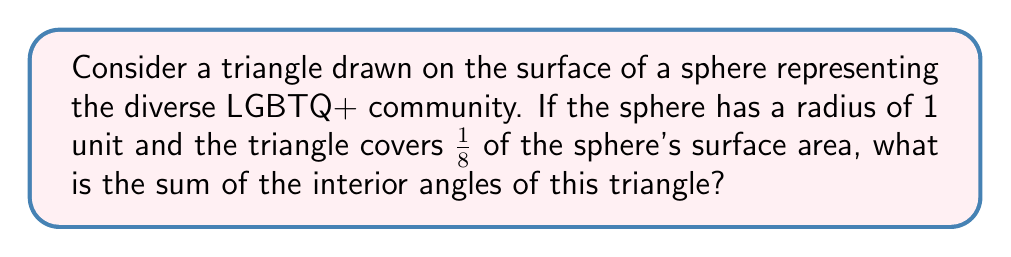Solve this math problem. Let's approach this step-by-step:

1) In non-Euclidean geometry on a sphere, the sum of angles in a triangle is greater than 180°. The excess over 180° is proportional to the area of the triangle.

2) The formula for the sum of angles in a spherical triangle is:
   $$\text{Angle Sum} = 180° + \frac{\text{Area of triangle}}{\text{Radius}^2} \cdot \frac{180°}{\pi}$$

3) We're given that the triangle covers 1/8 of the sphere's surface area. The surface area of a sphere is $4\pi r^2$.
   So, the area of our triangle is:
   $$\text{Area} = \frac{1}{8} \cdot 4\pi r^2 = \frac{\pi r^2}{2}$$

4) Substituting this into our formula, with $r = 1$:
   $$\text{Angle Sum} = 180° + \frac{\pi/2}{1^2} \cdot \frac{180°}{\pi}$$

5) Simplifying:
   $$\text{Angle Sum} = 180° + 90° = 270°$$

This result symbolizes how the diversity within the LGBTQ+ community expands beyond traditional boundaries, just as the angles in a spherical triangle sum to more than 180°.
Answer: 270° 